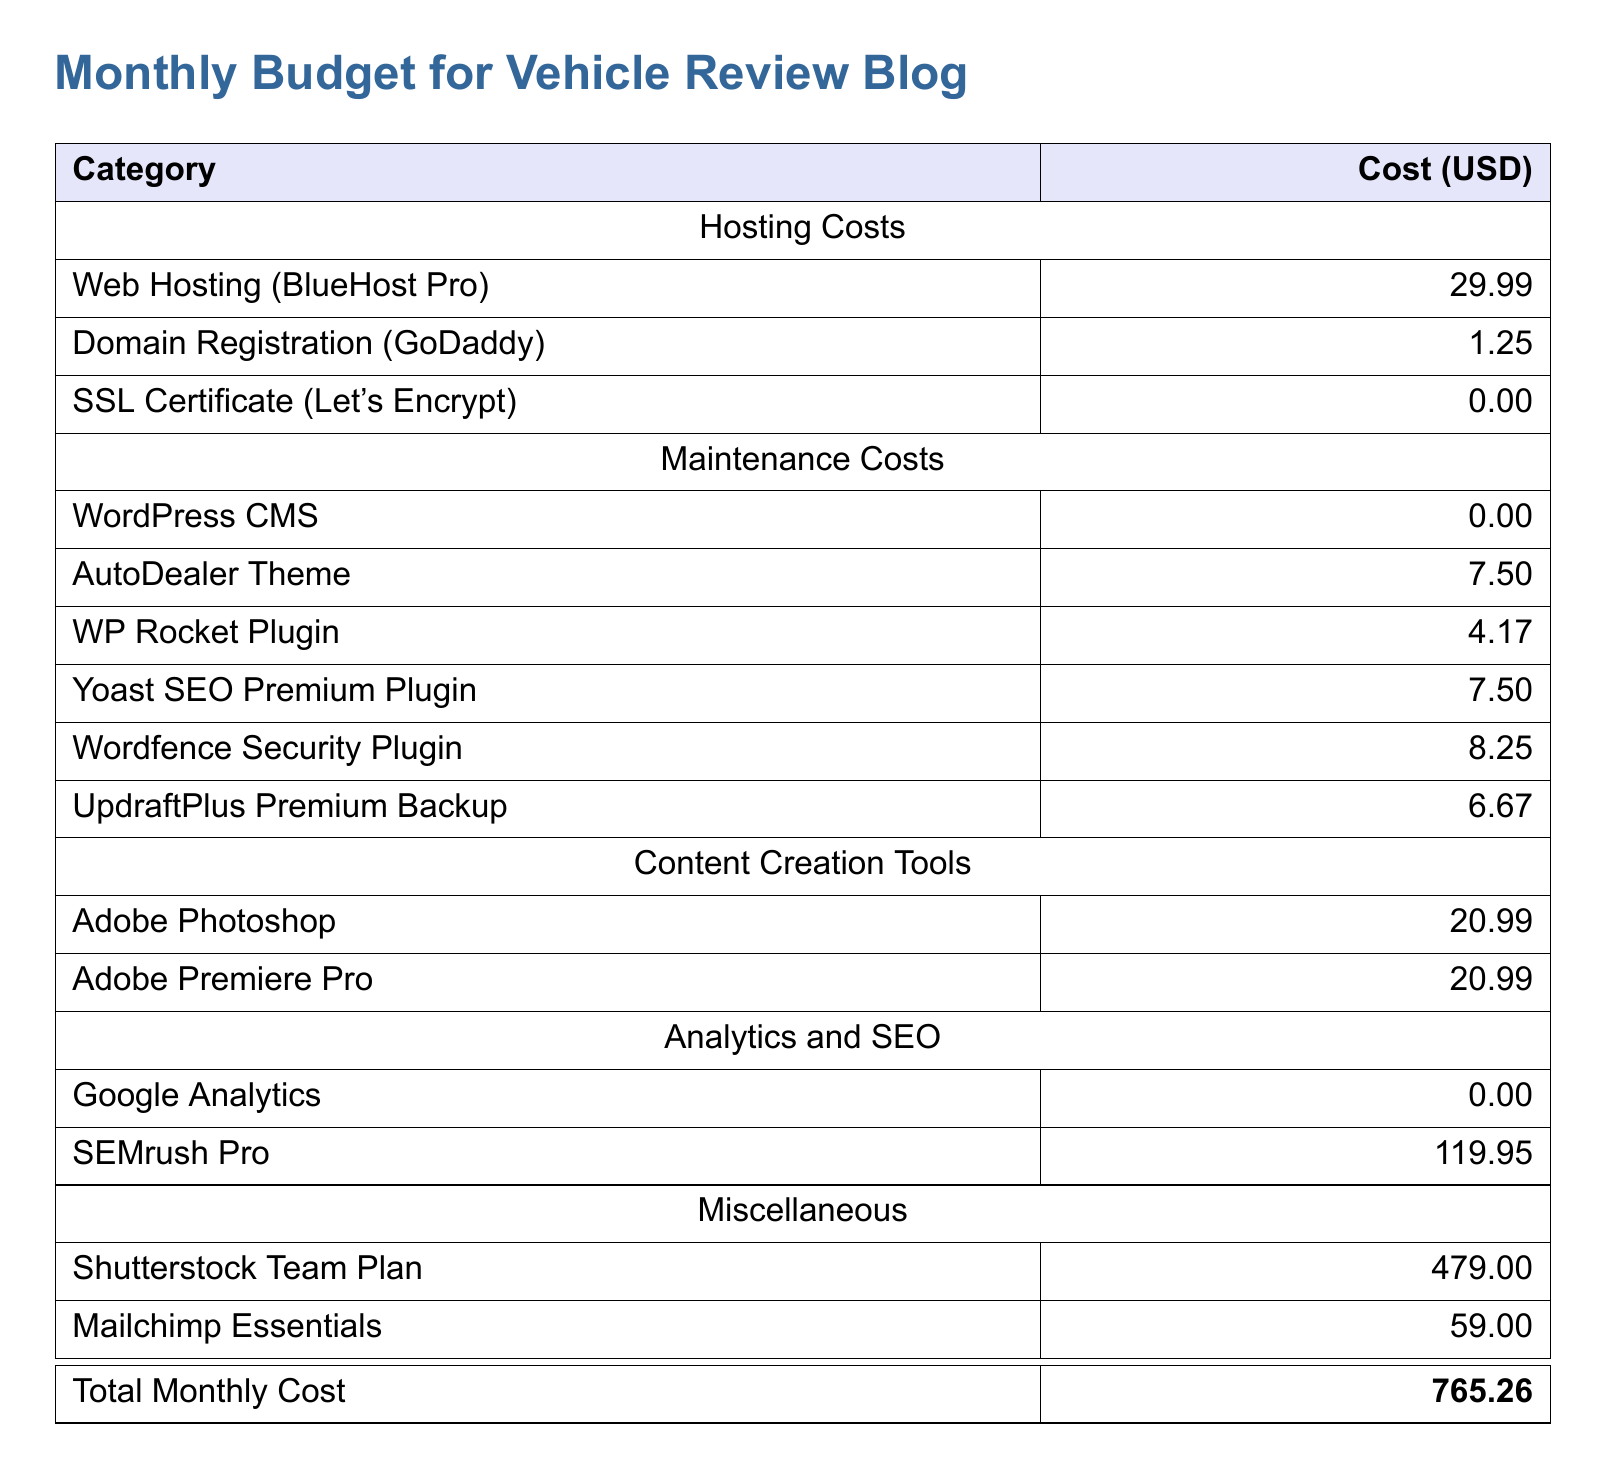What is the total monthly cost? The total monthly cost is the sum of all listed expenses in the document, which equals $765.26.
Answer: $765.26 How much does BlueHost Pro cost? The document states that the cost of BlueHost Pro for web hosting is $29.99.
Answer: $29.99 What is the cost of the Shutterstock Team Plan? The document shows that the Shutterstock Team Plan costs $479.00.
Answer: $479.00 How much is spent on SEO plugins? The total cost for SEO-related plugins is calculated by adding Yoast SEO Premium, which is $7.50, and Wordfence Security Plugin, which is $8.25, totaling $15.75.
Answer: $15.75 What are the costs for Adobe software? The document lists both Adobe Photoshop and Adobe Premiere Pro at $20.99 each, so the total for Adobe software is $41.98.
Answer: $41.98 What is the cost of the SSL Certificate? According to the document, the cost of the SSL Certificate from Let's Encrypt is $0.00.
Answer: $0.00 What is the monthly cost of the WP Rocket Plugin? The document states that the WP Rocket Plugin costs $4.17.
Answer: $4.17 How much does SEMrush Pro cost? SEMrush Pro is listed in the document as costing $119.95.
Answer: $119.95 What is the cost for the AutoDealer Theme? The document indicates that the cost of the AutoDealer Theme is $7.50.
Answer: $7.50 